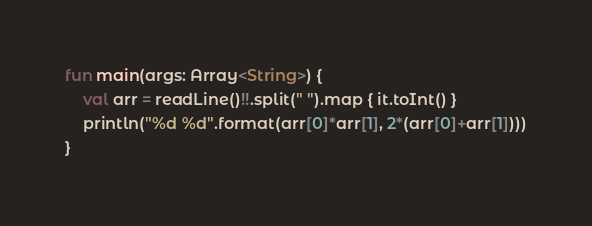Convert code to text. <code><loc_0><loc_0><loc_500><loc_500><_Kotlin_>fun main(args: Array<String>) {
    val arr = readLine()!!.split(" ").map { it.toInt() }
    println("%d %d".format(arr[0]*arr[1], 2*(arr[0]+arr[1])))
}
</code> 